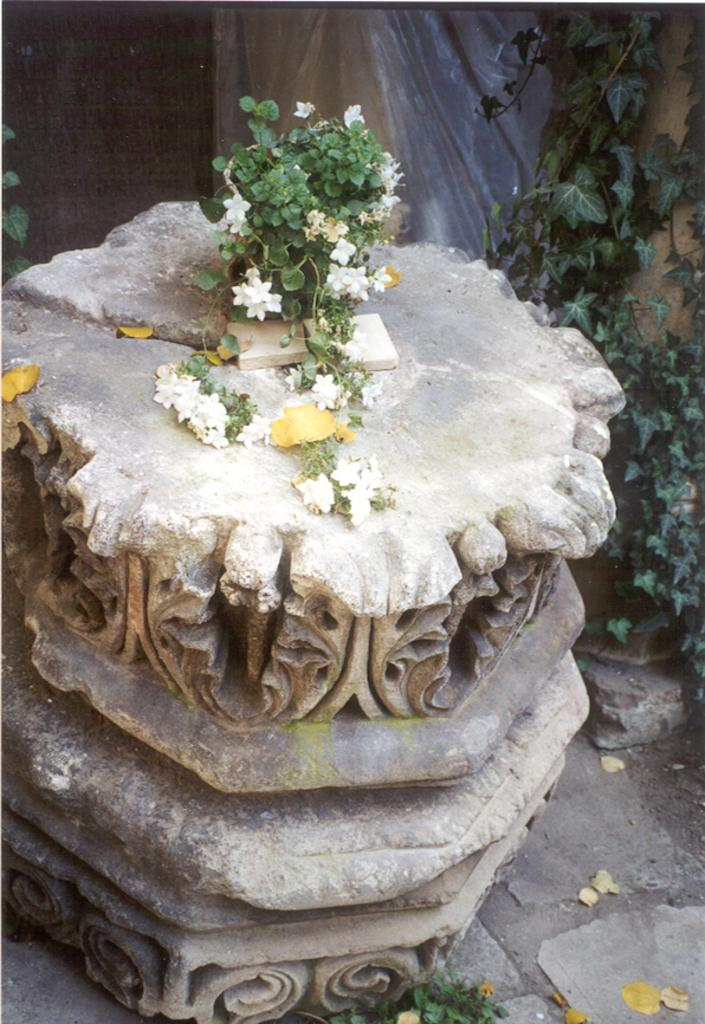What type of plant is featured in the image? There is a plant with flowers in the image. Where is the plant located? The plant is on a sculpture. What can be seen on the backside of the image? There are plants and a wall visible on the backside of the image. What type of boats can be seen in the image? There are no boats present in the image. What is the condition of the fire in the image? There is no fire present in the image. 